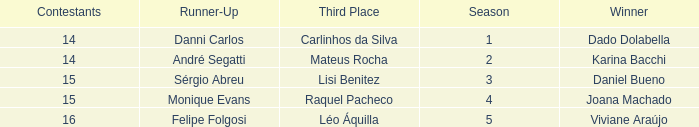How many contestants were there when the runner-up was Monique Evans? 15.0. 